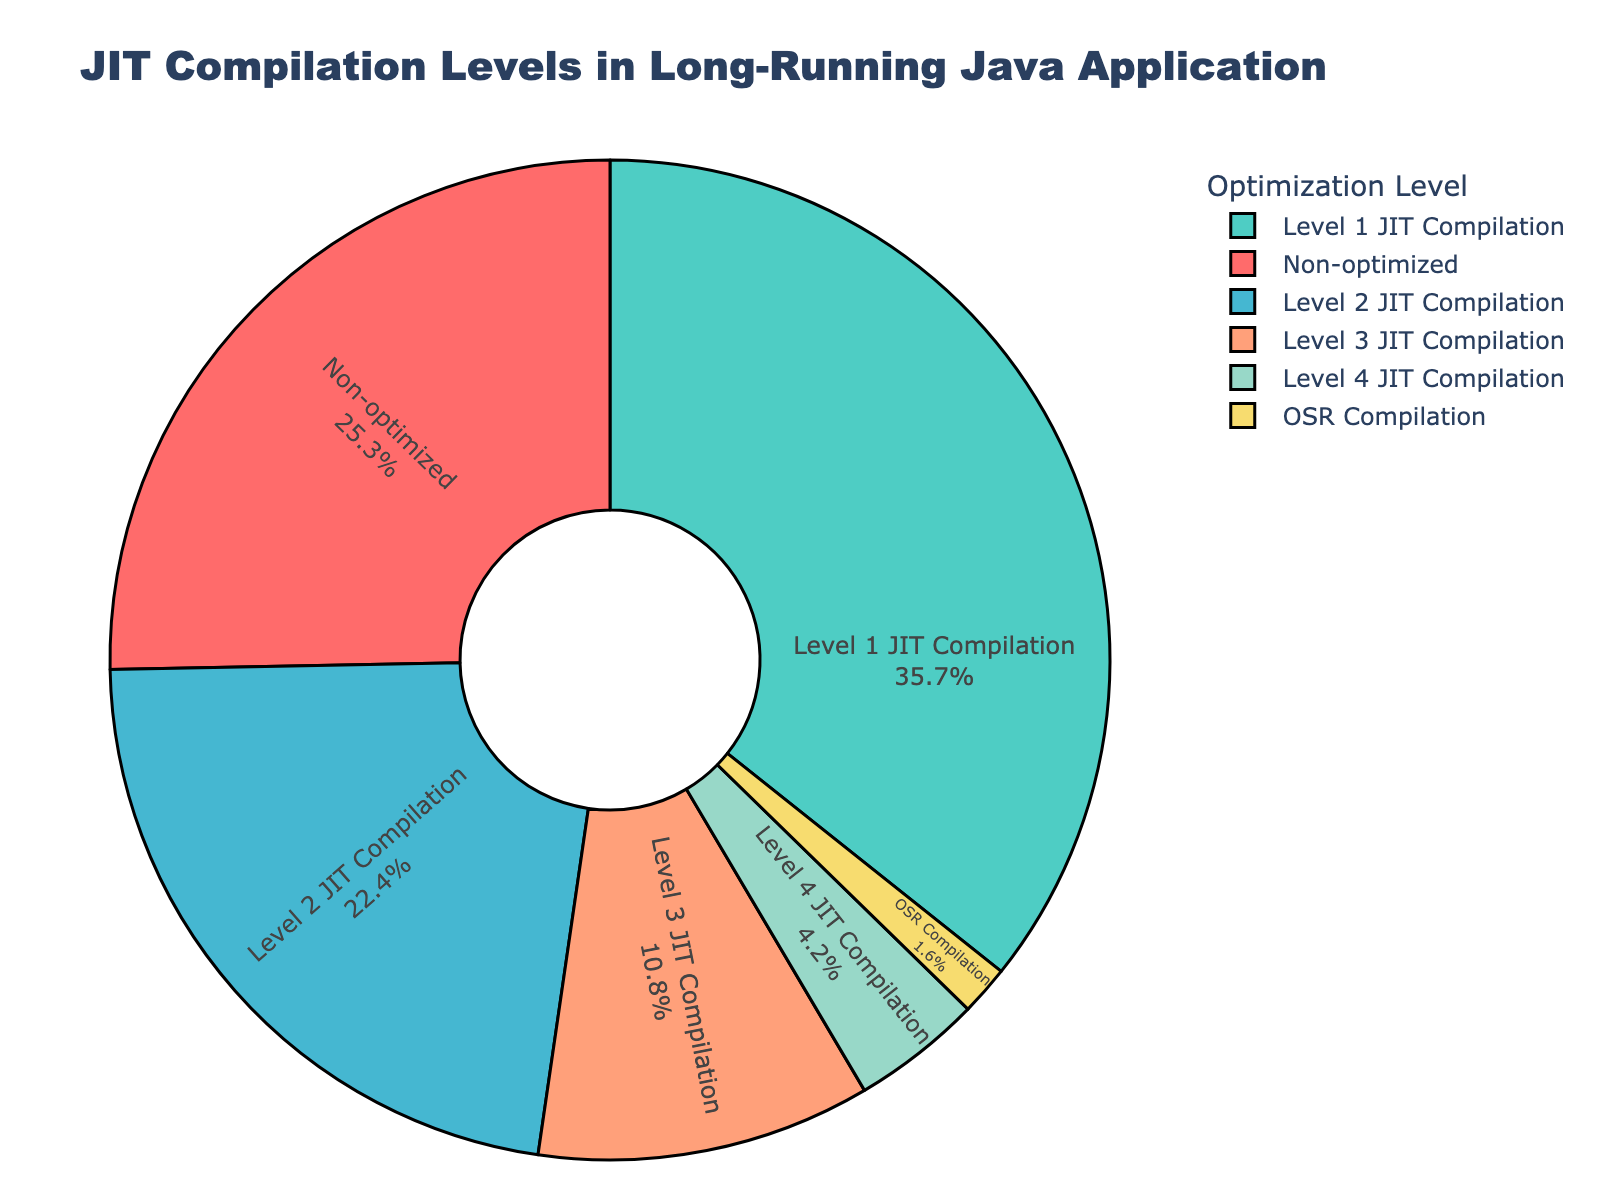What proportion of methods undergo the highest level of JIT compilation (Level 4)? The pie chart lists 'Level 4 JIT Compilation' with a percentage of 4.2%.
Answer: 4.2% Which optimization level has the largest proportion of methods optimized? The pie chart shows that 'Level 1 JIT Compilation' has the highest percentage at 35.7%.
Answer: Level 1 JIT Compilation How much greater is the proportion of methods at Level 1 JIT Compilation compared to Level 2 JIT Compilation? 'Level 1 JIT Compilation' has 35.7% and 'Level 2 JIT Compilation' has 22.4%. The difference is 35.7% - 22.4% = 13.3%.
Answer: 13.3% What proportion of methods are not optimized? The pie chart indicates 'Non-optimized' methods at 25.3%.
Answer: 25.3% Which optimization level is represented by the color red in the pie chart? According to the order of 'Method Type' and typical color assignment, 'Non-optimized' methods are often assigned the color red.
Answer: Non-optimized How does the proportion of methods optimized by OSR Compilation compare to Level 3 JIT Compilation? 'OSR Compilation' is at 1.6% while 'Level 3 JIT Compilation' is at 10.8%, so Level 3 JIT Compilation is significantly higher.
Answer: Level 3 JIT Compilation What is the sum of methods optimized by Level 3 and Level 4 JIT Compilation? 'Level 3 JIT Compilation' is 10.8% and 'Level 4 JIT Compilation' is 4.2%. The total is 10.8% + 4.2% = 15%.
Answer: 15% How many more methods are optimized by Level 1 JIT Compilation compared to those that are non-optimized? Level 1 JIT Compilation is 35.7%, and Non-optimized is 25.3%. The difference is 35.7% - 25.3% = 10.4%.
Answer: 10.4% Which optimization level has the smallest proportion of methods? The pie chart indicates that 'OSR Compilation' has the smallest proportion at 1.6%.
Answer: OSR Compilation 